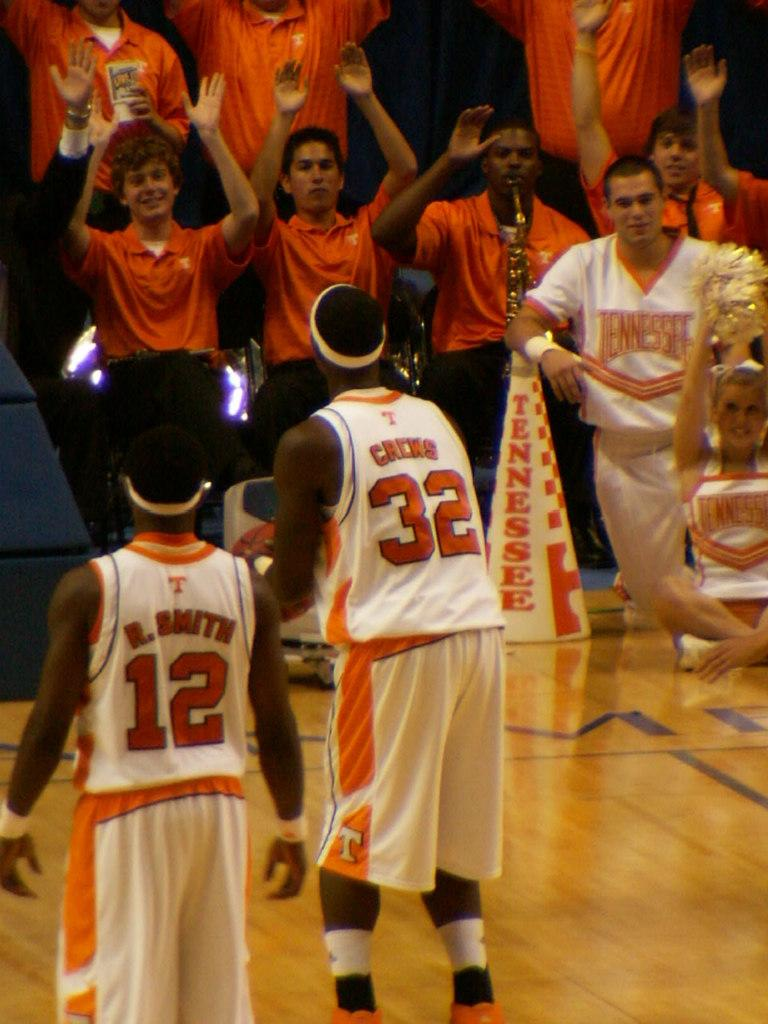<image>
Present a compact description of the photo's key features. Two sports players have the numbers 12 and 32 on their shirts. 